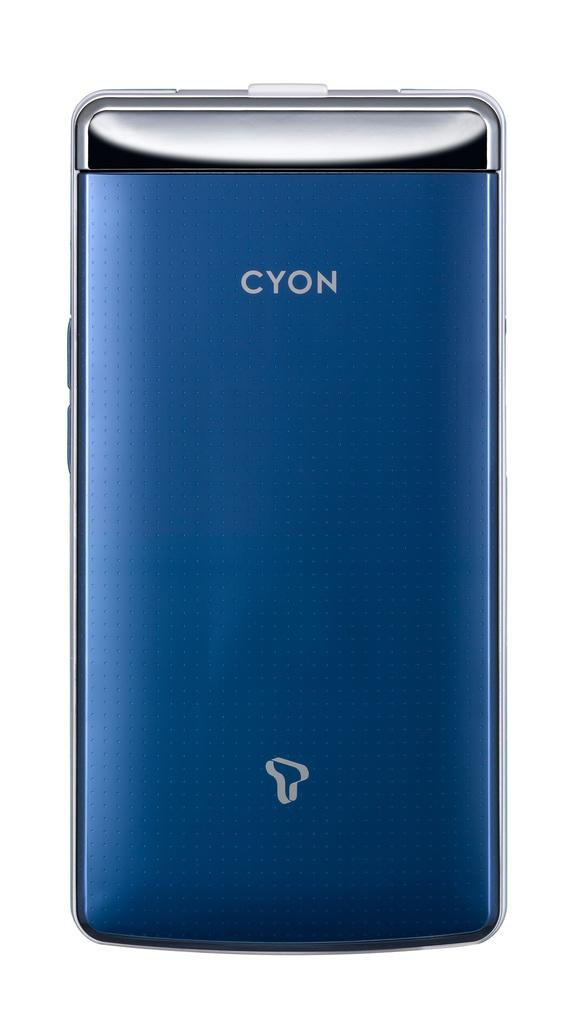<image>
Summarize the visual content of the image. A blue and silver Cyon phone is against a white back drop. 